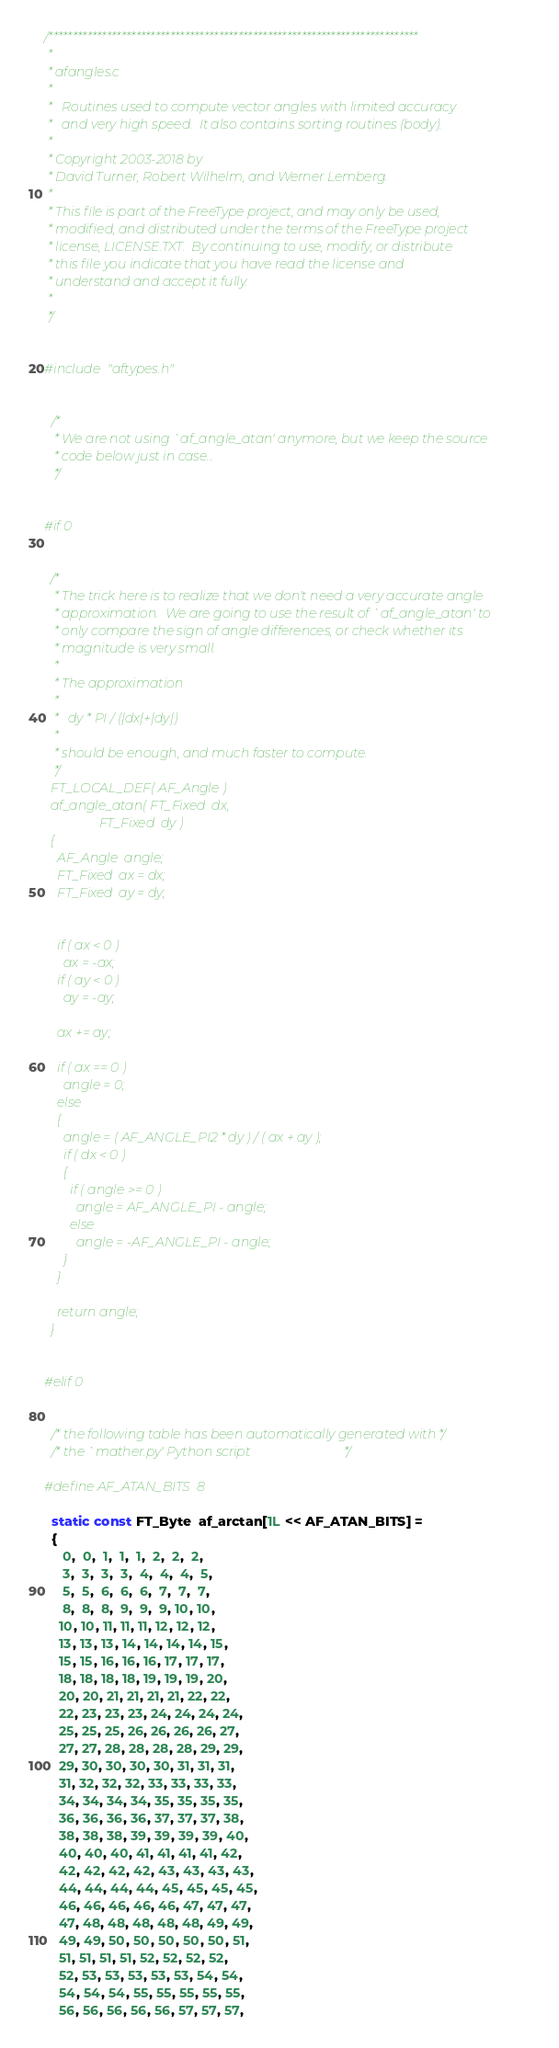<code> <loc_0><loc_0><loc_500><loc_500><_C_>/****************************************************************************
 *
 * afangles.c
 *
 *   Routines used to compute vector angles with limited accuracy
 *   and very high speed.  It also contains sorting routines (body).
 *
 * Copyright 2003-2018 by
 * David Turner, Robert Wilhelm, and Werner Lemberg.
 *
 * This file is part of the FreeType project, and may only be used,
 * modified, and distributed under the terms of the FreeType project
 * license, LICENSE.TXT.  By continuing to use, modify, or distribute
 * this file you indicate that you have read the license and
 * understand and accept it fully.
 *
 */


#include "aftypes.h"


  /*
   * We are not using `af_angle_atan' anymore, but we keep the source
   * code below just in case...
   */


#if 0


  /*
   * The trick here is to realize that we don't need a very accurate angle
   * approximation.  We are going to use the result of `af_angle_atan' to
   * only compare the sign of angle differences, or check whether its
   * magnitude is very small.
   *
   * The approximation
   *
   *   dy * PI / (|dx|+|dy|)
   *
   * should be enough, and much faster to compute.
   */
  FT_LOCAL_DEF( AF_Angle )
  af_angle_atan( FT_Fixed  dx,
                 FT_Fixed  dy )
  {
    AF_Angle  angle;
    FT_Fixed  ax = dx;
    FT_Fixed  ay = dy;


    if ( ax < 0 )
      ax = -ax;
    if ( ay < 0 )
      ay = -ay;

    ax += ay;

    if ( ax == 0 )
      angle = 0;
    else
    {
      angle = ( AF_ANGLE_PI2 * dy ) / ( ax + ay );
      if ( dx < 0 )
      {
        if ( angle >= 0 )
          angle = AF_ANGLE_PI - angle;
        else
          angle = -AF_ANGLE_PI - angle;
      }
    }

    return angle;
  }


#elif 0


  /* the following table has been automatically generated with */
  /* the `mather.py' Python script                             */

#define AF_ATAN_BITS  8

  static const FT_Byte  af_arctan[1L << AF_ATAN_BITS] =
  {
     0,  0,  1,  1,  1,  2,  2,  2,
     3,  3,  3,  3,  4,  4,  4,  5,
     5,  5,  6,  6,  6,  7,  7,  7,
     8,  8,  8,  9,  9,  9, 10, 10,
    10, 10, 11, 11, 11, 12, 12, 12,
    13, 13, 13, 14, 14, 14, 14, 15,
    15, 15, 16, 16, 16, 17, 17, 17,
    18, 18, 18, 18, 19, 19, 19, 20,
    20, 20, 21, 21, 21, 21, 22, 22,
    22, 23, 23, 23, 24, 24, 24, 24,
    25, 25, 25, 26, 26, 26, 26, 27,
    27, 27, 28, 28, 28, 28, 29, 29,
    29, 30, 30, 30, 30, 31, 31, 31,
    31, 32, 32, 32, 33, 33, 33, 33,
    34, 34, 34, 34, 35, 35, 35, 35,
    36, 36, 36, 36, 37, 37, 37, 38,
    38, 38, 38, 39, 39, 39, 39, 40,
    40, 40, 40, 41, 41, 41, 41, 42,
    42, 42, 42, 42, 43, 43, 43, 43,
    44, 44, 44, 44, 45, 45, 45, 45,
    46, 46, 46, 46, 46, 47, 47, 47,
    47, 48, 48, 48, 48, 48, 49, 49,
    49, 49, 50, 50, 50, 50, 50, 51,
    51, 51, 51, 51, 52, 52, 52, 52,
    52, 53, 53, 53, 53, 53, 54, 54,
    54, 54, 54, 55, 55, 55, 55, 55,
    56, 56, 56, 56, 56, 57, 57, 57,</code> 